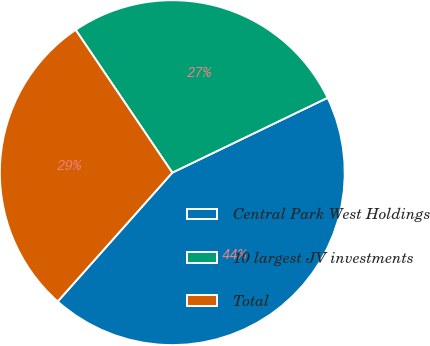Convert chart to OTSL. <chart><loc_0><loc_0><loc_500><loc_500><pie_chart><fcel>Central Park West Holdings<fcel>10 largest JV investments<fcel>Total<nl><fcel>43.72%<fcel>27.32%<fcel>28.96%<nl></chart> 